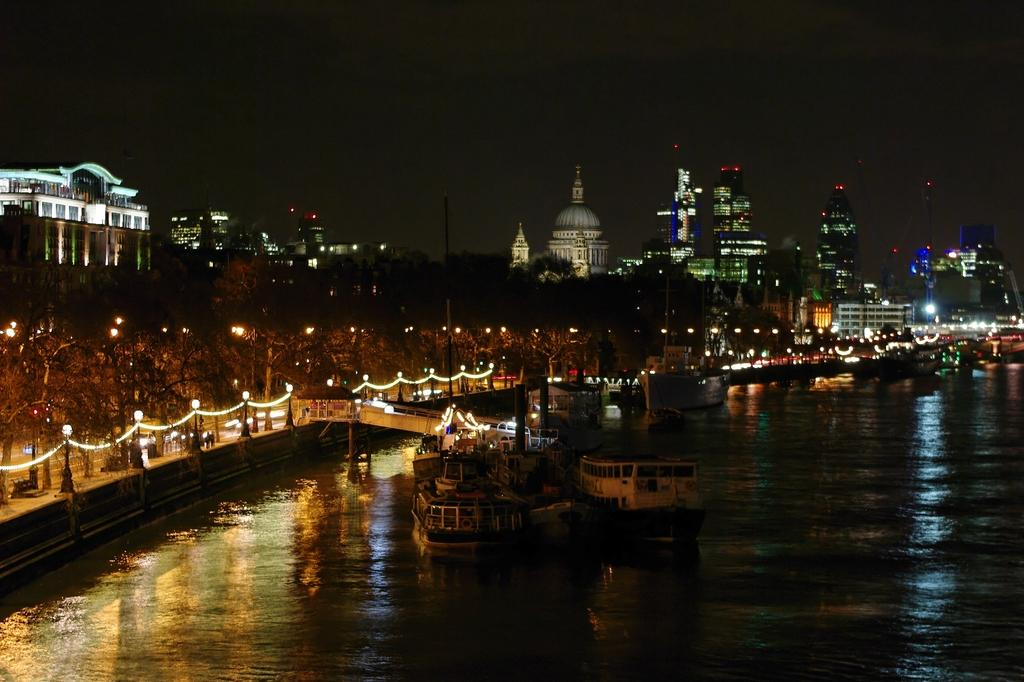What type of structures can be seen in the image? There are buildings in the image. What other objects are present in the image? There are lights, poles, trees, and serial lights visible in the image. Can you describe the water feature in the image? There are boats on a river in the image. What is visible in the sky in the image? The sky is visible in the image. Where is the badge located in the image? There is no badge present in the image. What type of soap is being used to clean the boats in the image? There is no soap or cleaning activity depicted in the image; it only shows boats on a river. 